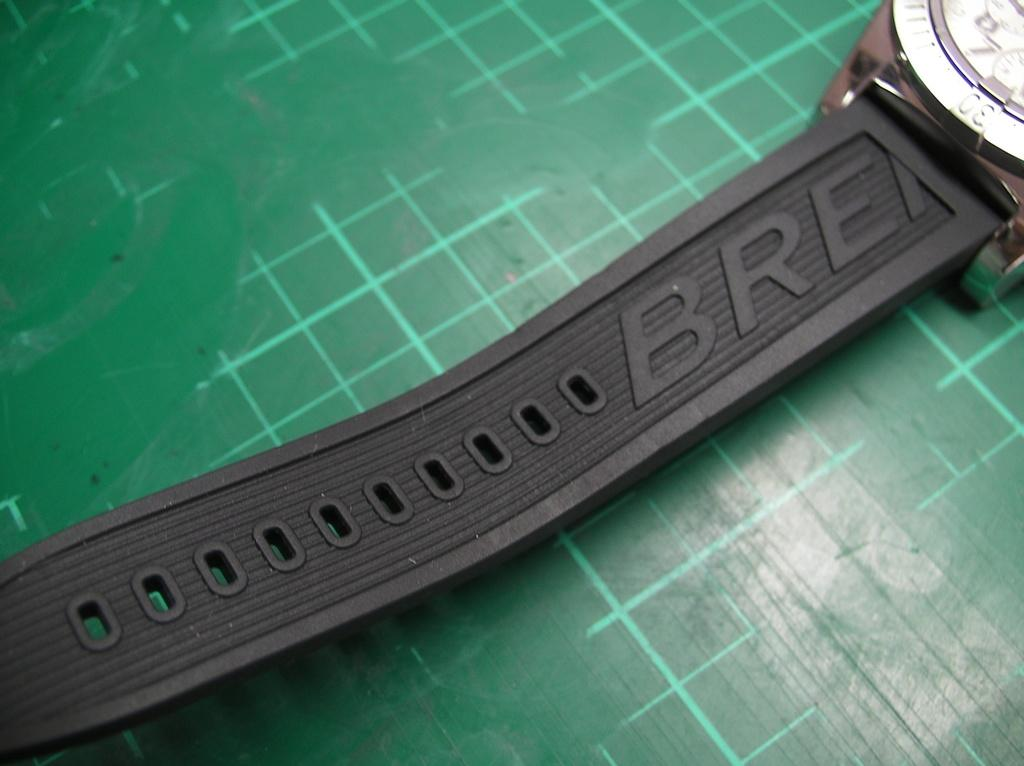<image>
Write a terse but informative summary of the picture. green grid and watch with letters BRE on band 